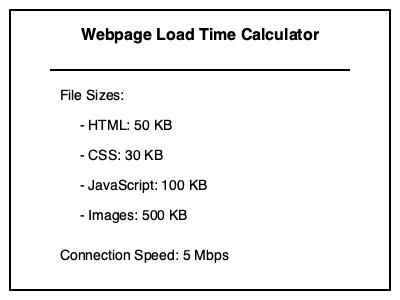As a web developer, you need to estimate the load time of a webpage. Given the file sizes and connection speed shown in the image, calculate the approximate time it would take to load this webpage. Round your answer to the nearest tenth of a second. To calculate the load time, we'll follow these steps:

1. Convert all file sizes to bits:
   HTML: $50 \text{ KB} \times 8 = 400 \text{ Kb}$
   CSS: $30 \text{ KB} \times 8 = 240 \text{ Kb}$
   JavaScript: $100 \text{ KB} \times 8 = 800 \text{ Kb}$
   Images: $500 \text{ KB} \times 8 = 4000 \text{ Kb}$

2. Calculate total file size in bits:
   $\text{Total} = 400 + 240 + 800 + 4000 = 5440 \text{ Kb}$

3. Convert connection speed to Kbps:
   $5 \text{ Mbps} = 5000 \text{ Kbps}$

4. Calculate load time:
   $\text{Load time} = \frac{\text{Total file size}}{\text{Connection speed}}$
   $= \frac{5440 \text{ Kb}}{5000 \text{ Kbps}} = 1.088 \text{ seconds}$

5. Round to the nearest tenth:
   $1.088 \text{ seconds} \approx 1.1 \text{ seconds}$
Answer: 1.1 seconds 